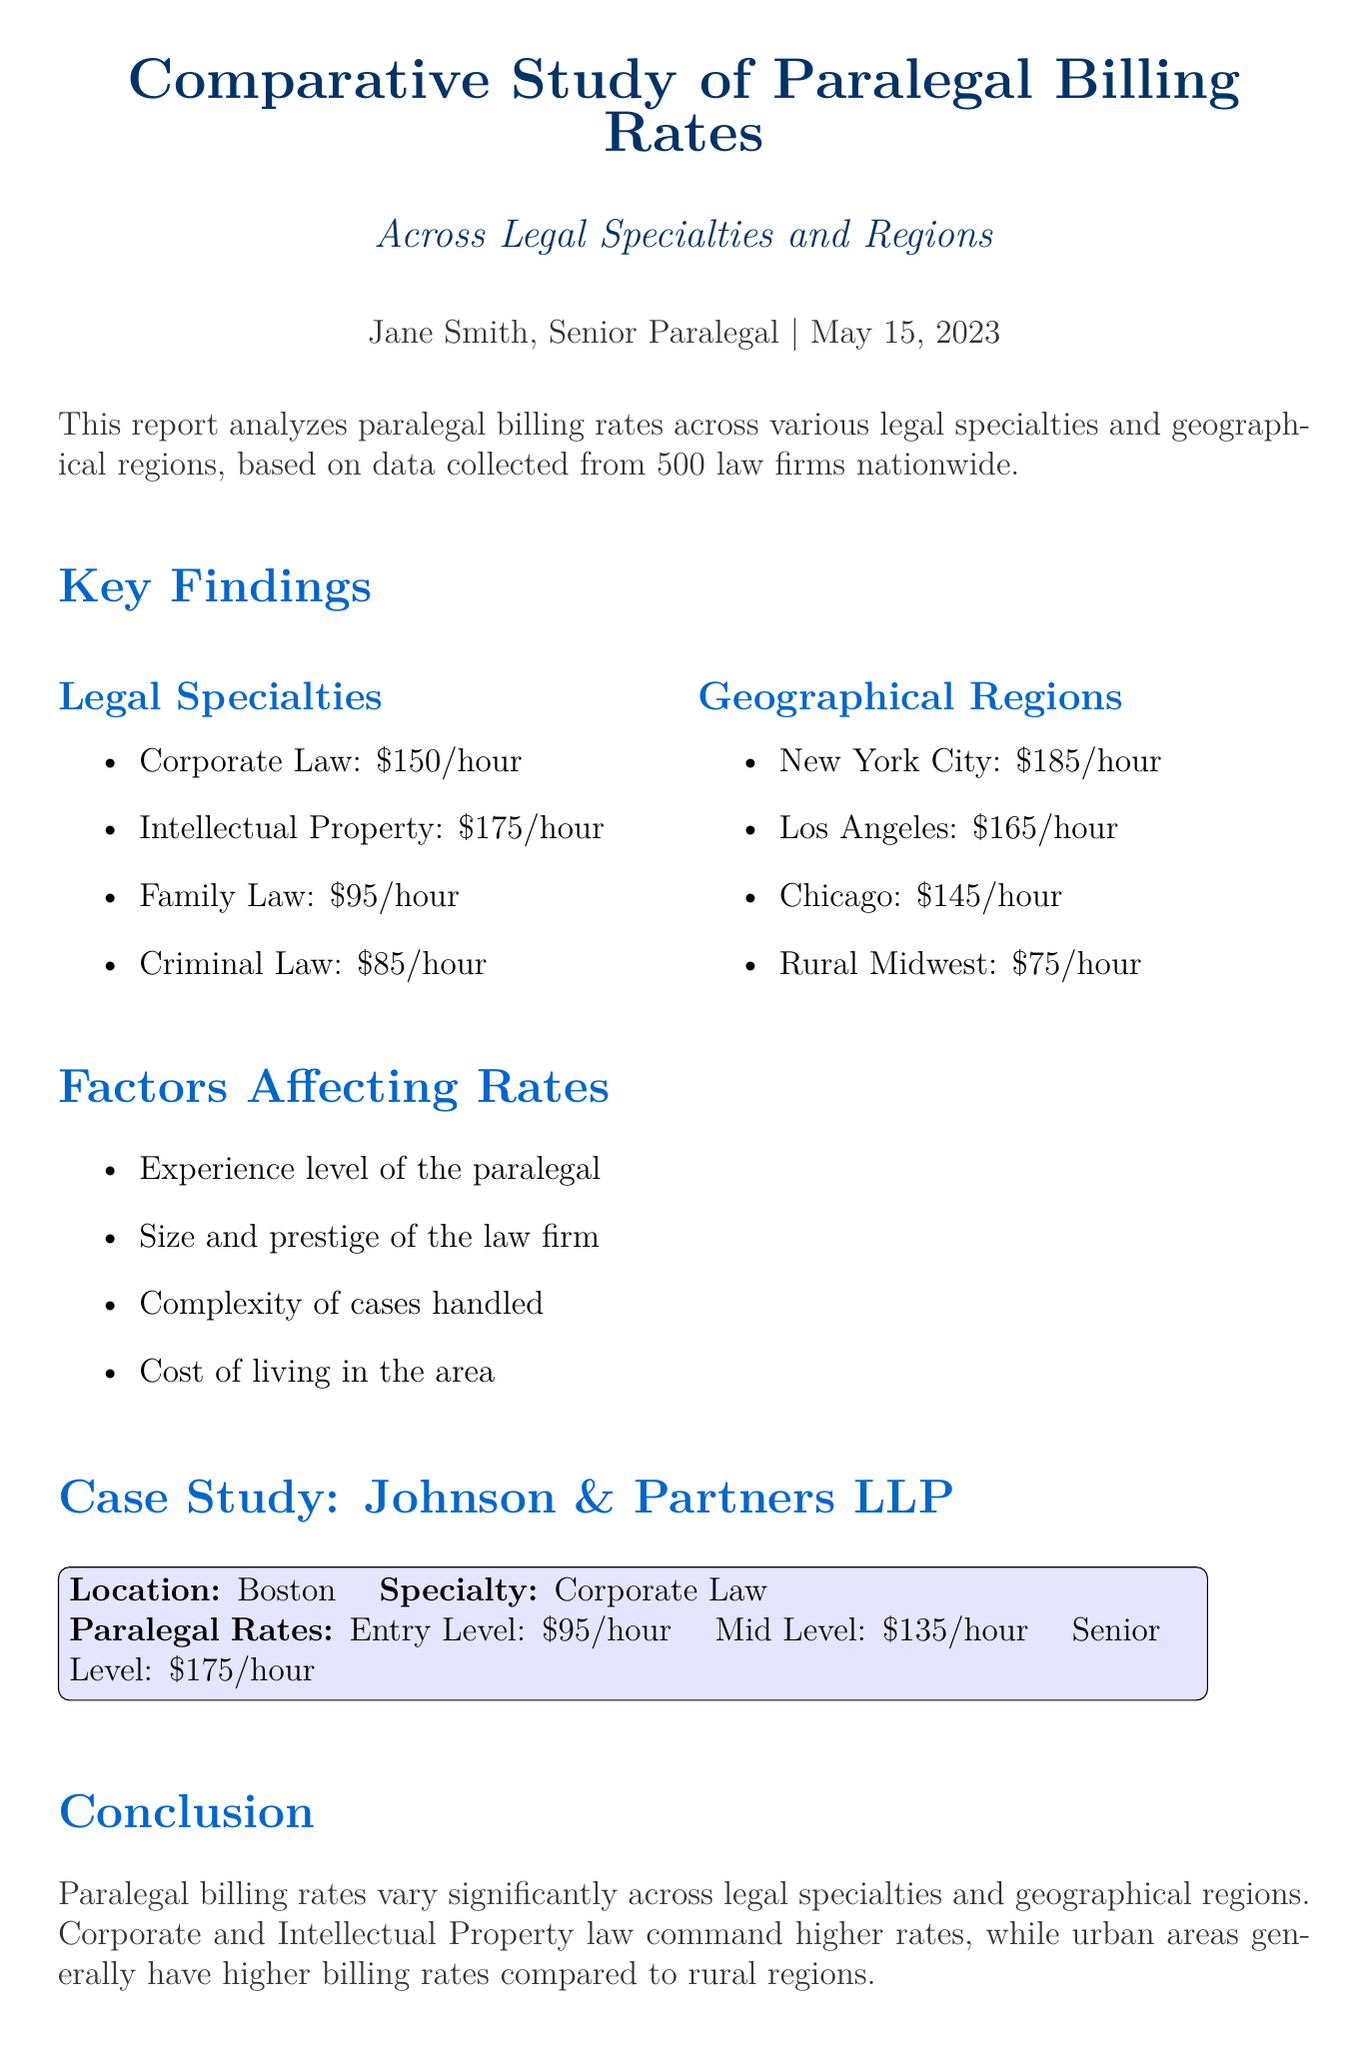What is the title of the report? The title is explicitly stated at the beginning of the document.
Answer: Comparative Study of Paralegal Billing Rates Across Legal Specialties and Regions Who is the author of the report? The author name is mentioned directly below the title in the document.
Answer: Jane Smith, Senior Paralegal What is the average billing rate for Family Law? The document lists specific average rates for each legal specialty, including Family Law.
Answer: $95/hour Which region has the highest average billing rate? The document provides a list of regions and their corresponding rates, indicating the highest.
Answer: New York City What factor is NOT mentioned as affecting paralegal rates? The document lists several factors affecting rates, allowing us to identify any omitted factors.
Answer: None (All listed factors are mentioned) What is the average billing rate for Intellectual Property? The average billing rate for each specialty is specified in the key findings section.
Answer: $175/hour What billing rate does Johnson & Partners LLP charge for entry-level paralegals? The case study section outlines the paralegal rates at Johnson & Partners LLP, identifying entry-level billing.
Answer: $95/hour Which two specialties command higher rates according to the report? The report compares specialties and notes which command higher rates.
Answer: Corporate and Intellectual Property law What geographical area has the lowest average billing rate? The geographical regions and their rates are listed, highlighting the lowest.
Answer: Rural Midwest 